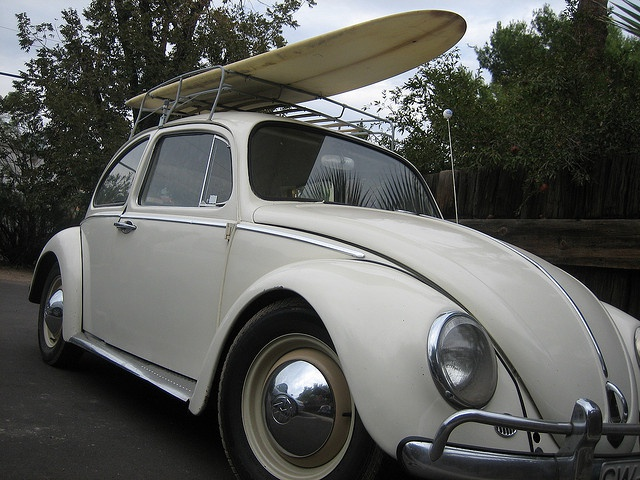Describe the objects in this image and their specific colors. I can see car in lightgray, darkgray, gray, and black tones and surfboard in lightgray, gray, and black tones in this image. 